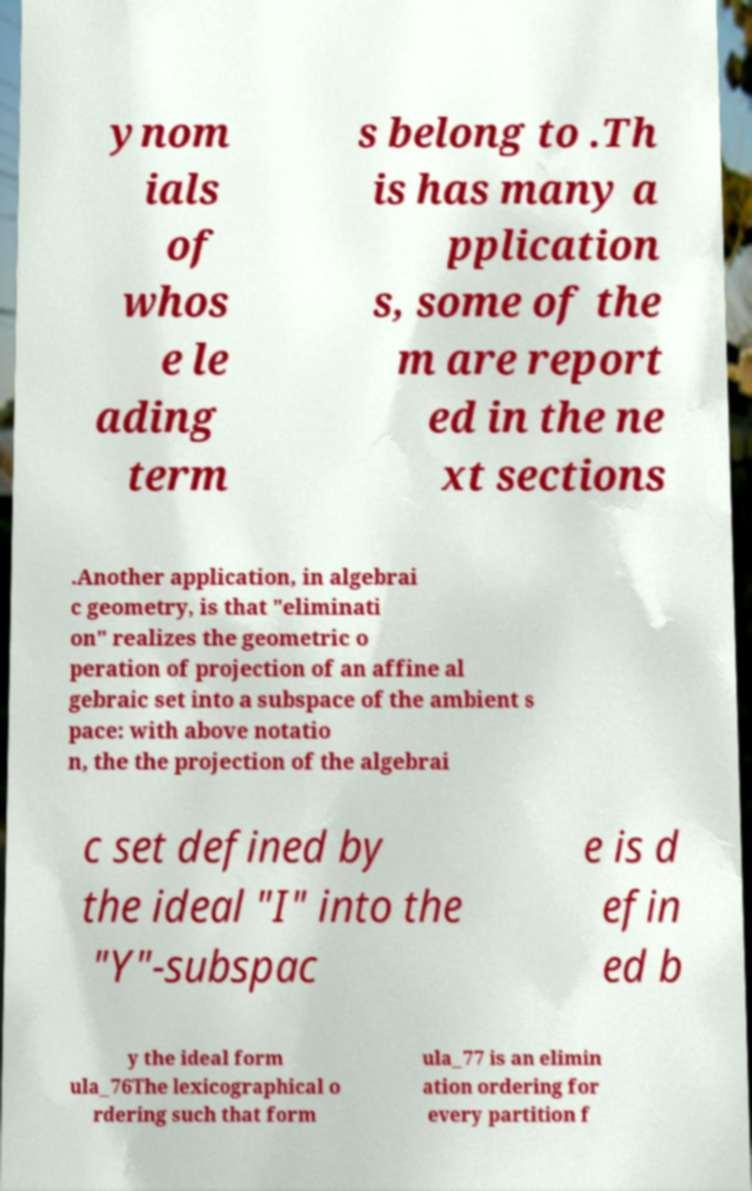Please identify and transcribe the text found in this image. ynom ials of whos e le ading term s belong to .Th is has many a pplication s, some of the m are report ed in the ne xt sections .Another application, in algebrai c geometry, is that "eliminati on" realizes the geometric o peration of projection of an affine al gebraic set into a subspace of the ambient s pace: with above notatio n, the the projection of the algebrai c set defined by the ideal "I" into the "Y"-subspac e is d efin ed b y the ideal form ula_76The lexicographical o rdering such that form ula_77 is an elimin ation ordering for every partition f 